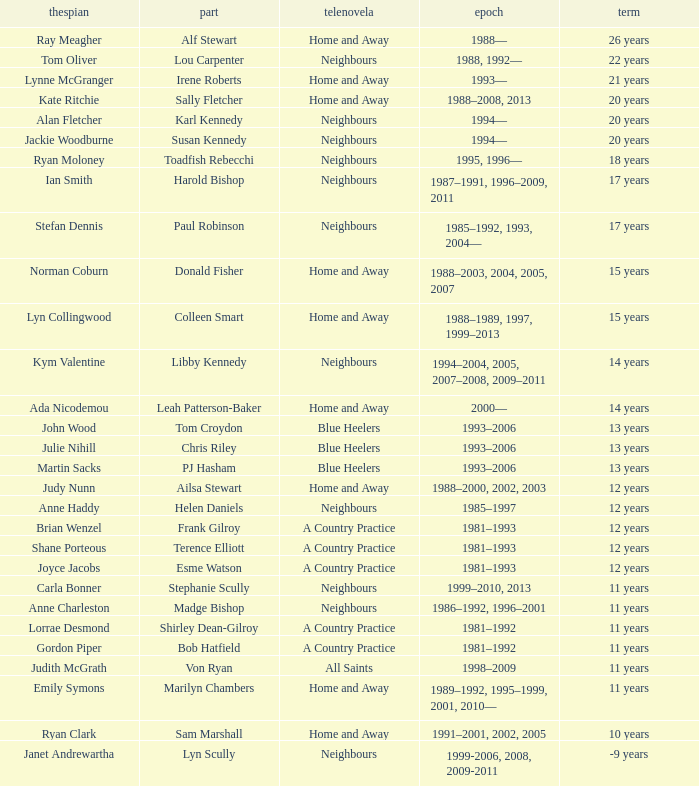Which actor played Harold Bishop for 17 years? Ian Smith. 